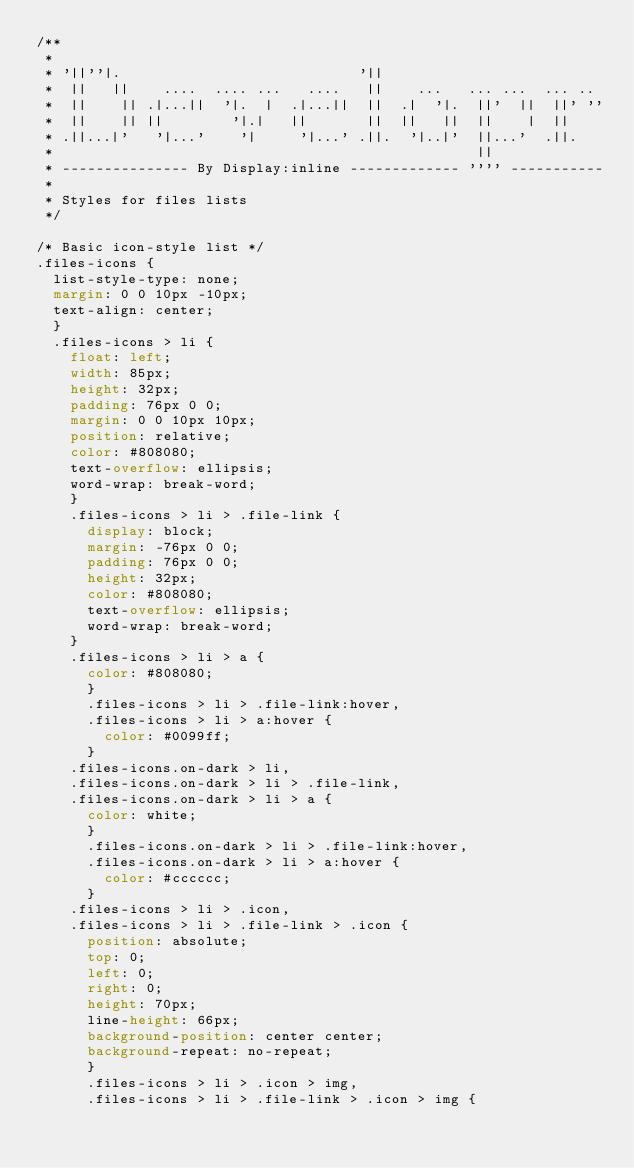<code> <loc_0><loc_0><loc_500><loc_500><_CSS_>/**
 *
 * '||''|.                            '||
 *  ||   ||    ....  .... ...   ....   ||    ...   ... ...  ... ..
 *  ||    || .|...||  '|.  |  .|...||  ||  .|  '|.  ||'  ||  ||' ''
 *  ||    || ||        '|.|   ||       ||  ||   ||  ||    |  ||
 * .||...|'   '|...'    '|     '|...' .||.  '|..|'  ||...'  .||.
 *                                                  ||
 * --------------- By Display:inline ------------- '''' -----------
 *
 * Styles for files lists
 */

/* Basic icon-style list */
.files-icons {
	list-style-type: none;
	margin: 0 0 10px -10px;
	text-align: center;
	}
	.files-icons > li {
		float: left;
		width: 85px;
		height: 32px;
		padding: 76px 0 0;
		margin: 0 0 10px 10px;
		position: relative;
		color: #808080;
		text-overflow: ellipsis;
		word-wrap: break-word;
		}
		.files-icons > li > .file-link {
			display: block;
			margin: -76px 0 0;
			padding: 76px 0 0;
			height: 32px;
			color: #808080;
			text-overflow: ellipsis;
			word-wrap: break-word;
		}
		.files-icons > li > a {
			color: #808080;
			}
			.files-icons > li > .file-link:hover,
			.files-icons > li > a:hover {
				color: #0099ff;
			}
		.files-icons.on-dark > li,
		.files-icons.on-dark > li > .file-link,
		.files-icons.on-dark > li > a {
			color: white;
			}
			.files-icons.on-dark > li > .file-link:hover,
			.files-icons.on-dark > li > a:hover {
				color: #cccccc;
			}
		.files-icons > li > .icon,
		.files-icons > li > .file-link > .icon {
			position: absolute;
			top: 0;
			left: 0;
			right: 0;
			height: 70px;
			line-height: 66px;
			background-position: center center;
			background-repeat: no-repeat;
			}
			.files-icons > li > .icon > img,
			.files-icons > li > .file-link > .icon > img {</code> 